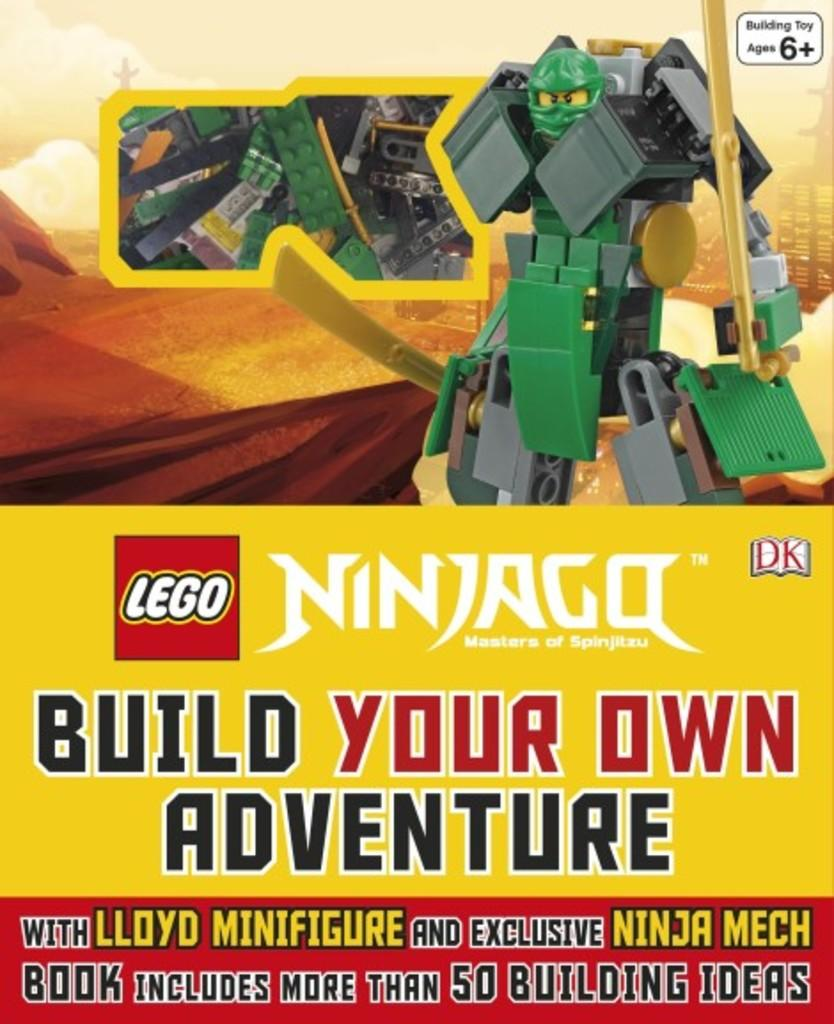<image>
Render a clear and concise summary of the photo. Poster of a Lego samurai that says "Build your own adventure". 